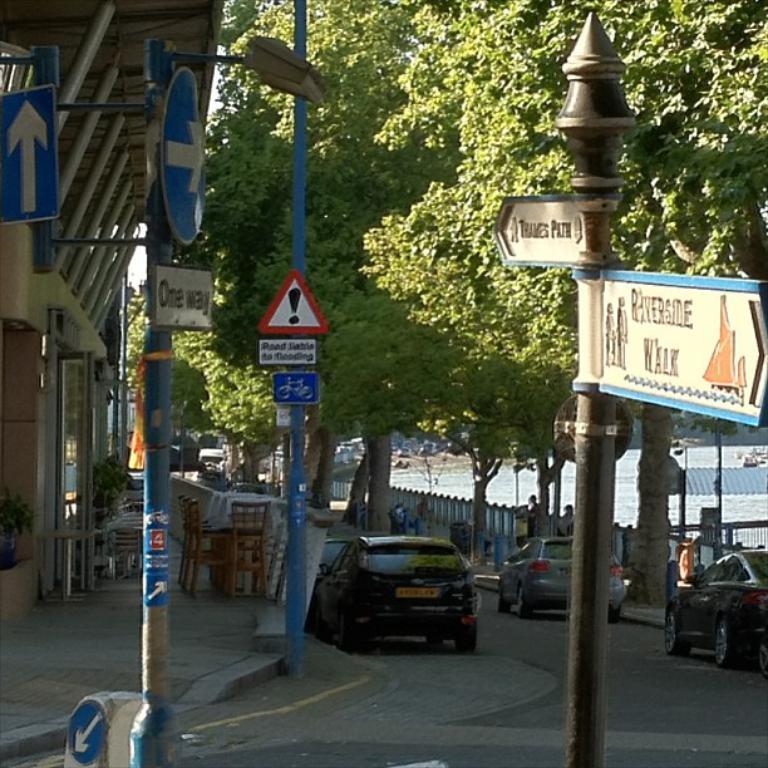Can you describe this image briefly? In this image there are cars, beside the cars there are trees and a railing. 